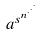<formula> <loc_0><loc_0><loc_500><loc_500>a ^ { s ^ { n ^ { \cdot ^ { \cdot ^ { \cdot } } } } }</formula> 